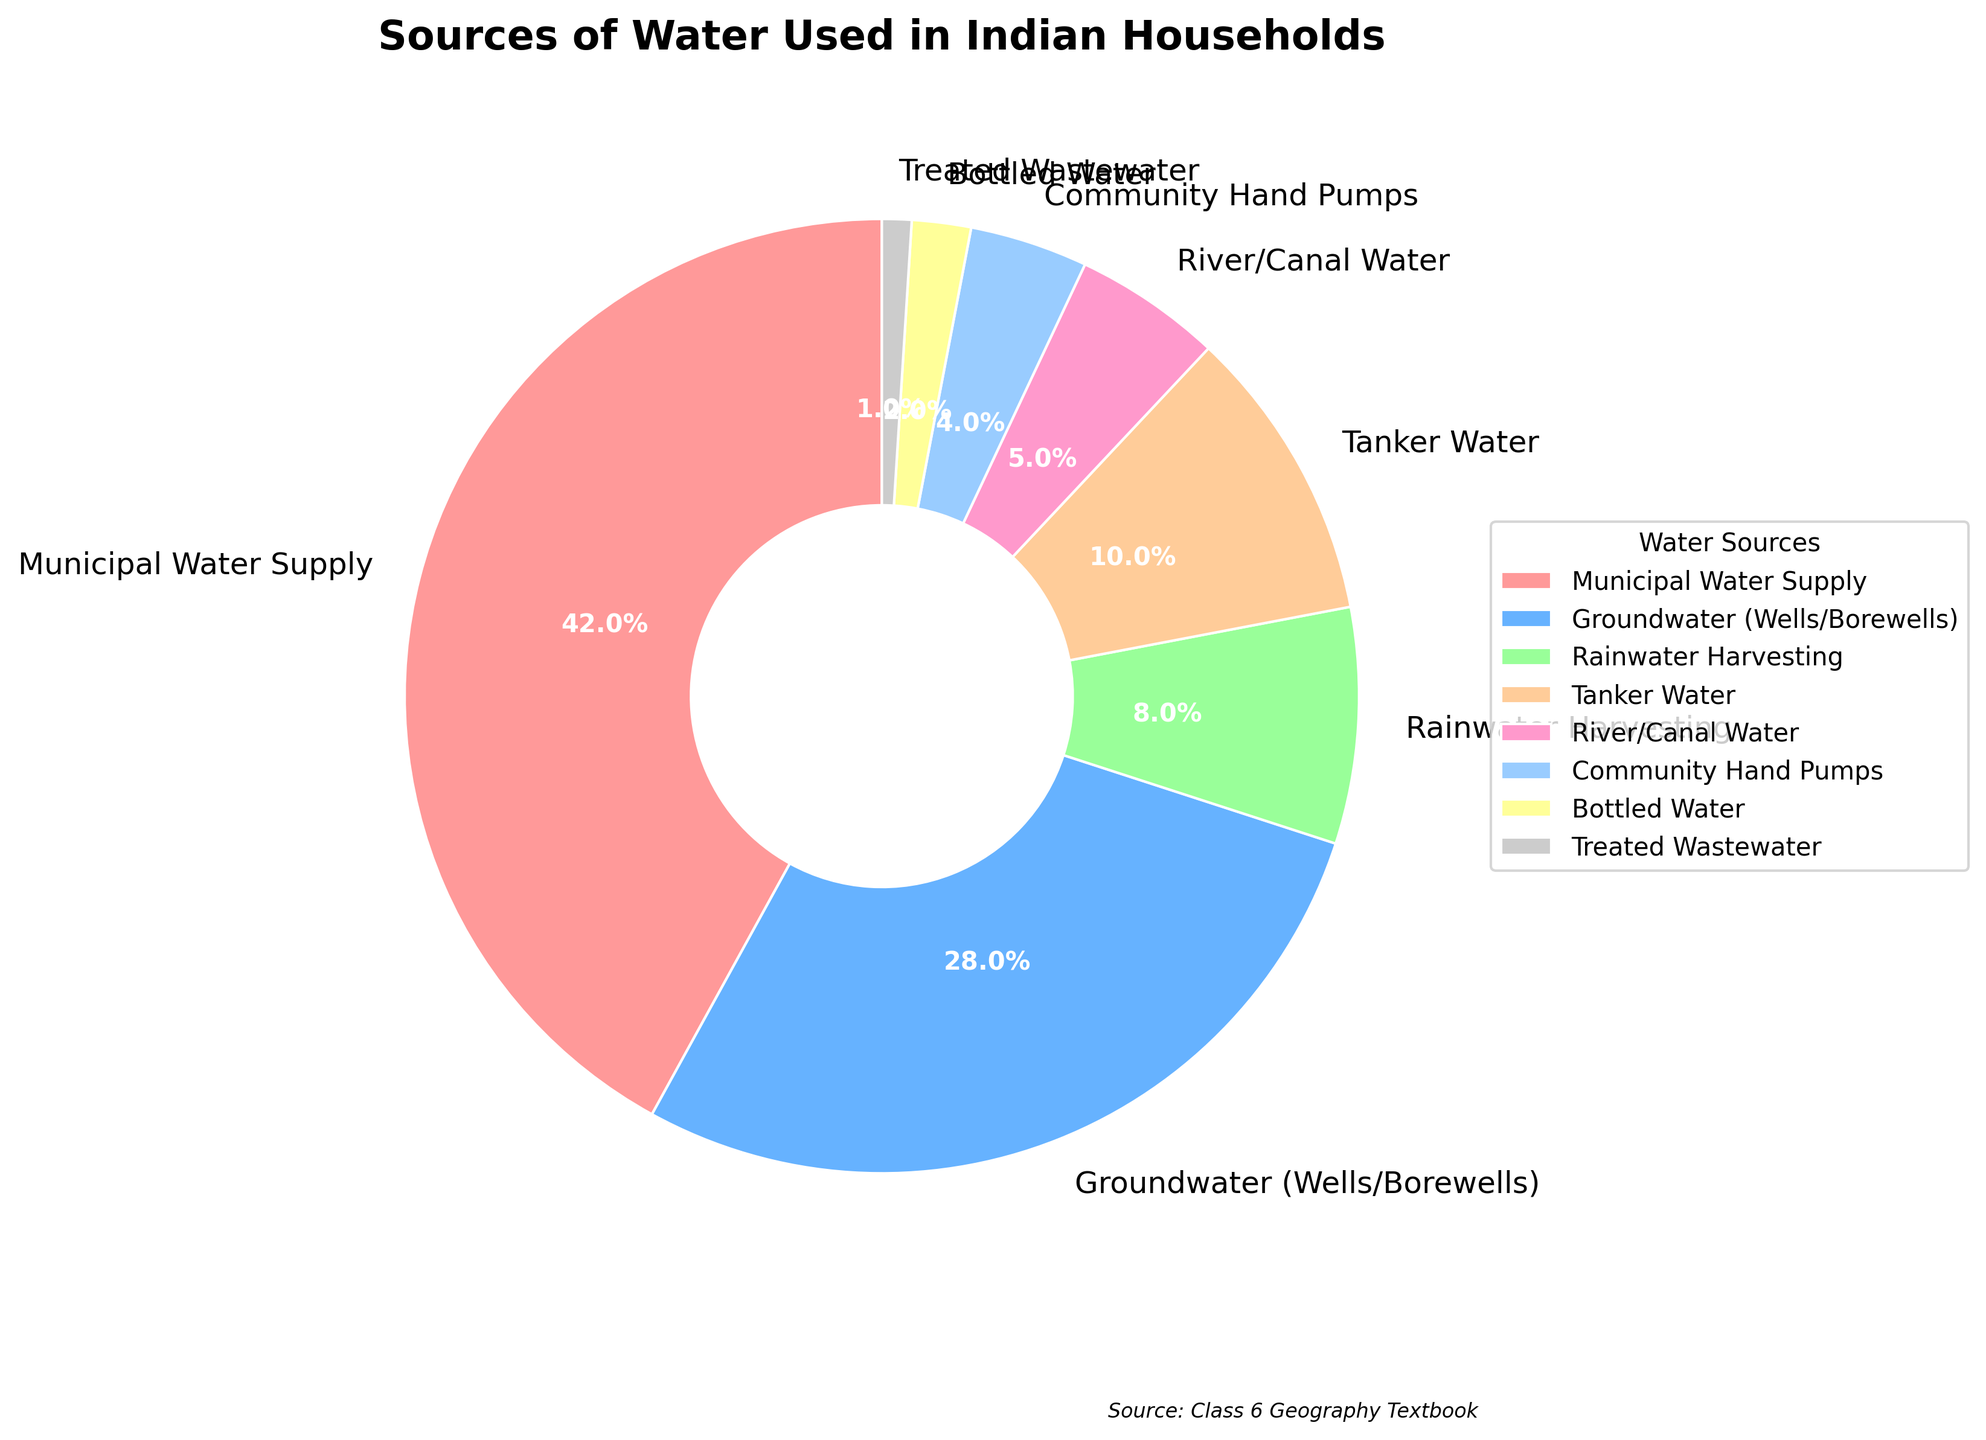What percentage of households use groundwater as their water source? Refer to the section labeled "Groundwater (Wells/Borewells)" on the pie chart and check the percentage written there.
Answer: 28% Which water source is used by the smallest percentage of households? Look at the pie chart to find the smallest slice and read its label to see which source it corresponds to.
Answer: Treated Wastewater What is the sum of the percentages of households using Municipal Water Supply and Community Hand Pumps? Find the percentages for "Municipal Water Supply" and "Community Hand Pumps" from the pie chart and add them together: 42% + 4%.
Answer: 46% Compare the usage of Rainwater Harvesting and Tanker Water. Which one is more widely used? Check the pie chart for the percentages of "Rainwater Harvesting" and "Tanker Water" and determine which is higher.
Answer: Tanker Water Which water source has a percentage that is closest to 10%? Examine the pie chart to locate the sections closest to 10% and read their labels.
Answer: Tanker Water What is the difference in usage percentage between bottled water and river/canal water? Find the percentages for "Bottled Water" and "River/Canal Water" on the pie chart and subtract the smaller percentage from the larger one: 5% - 2%.
Answer: 3% How does the percentage of households using municipal water supply compare to those using groundwater sources? Look at the percentages for "Municipal Water Supply" and "Groundwater (Wells/Borewells)" and see which is larger and by how much: 42% vs. 28%.
Answer: Municipal Water Supply is 14% more If you combine the percentages of all non-municipal water sources, what value do you get? Add the percentages of all water sources except "Municipal Water Supply": 28% + 8% + 10% + 5% + 4% + 2% + 1%.
Answer: 58% What is the percentage difference between the combined usage of river/canal water and community hand pumps versus the usage of rainwater harvesting? Add the percentages of "River/Canal Water" and "Community Hand Pumps" together and then subtract it from the percentage of "Rainwater Harvesting": (5% + 4%) - 8%.
Answer: 1% If you group all water sources with less than 10% usage together, what percentage do they collectively represent? Add the percentages of water sources with less than 10% usage: 8% (Rainwater Harvesting) + 5% (River/Canal Water) + 4% (Community Hand Pumps) + 2% (Bottled Water) + 1% (Treated Wastewater).
Answer: 20% 